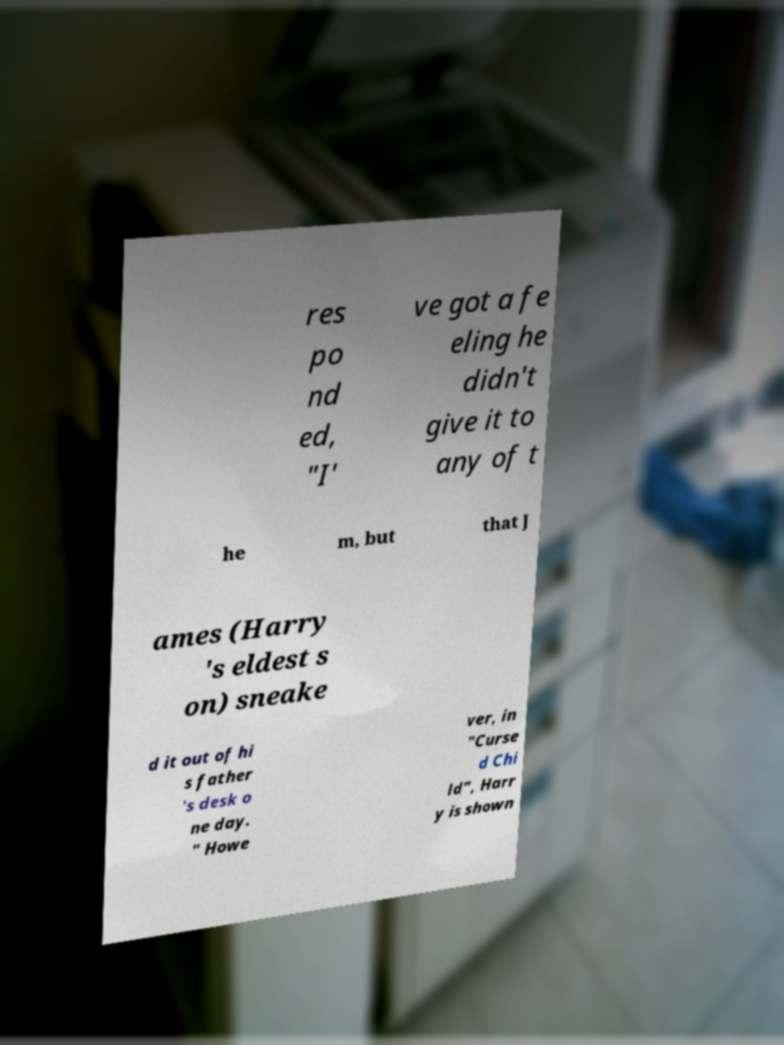Please read and relay the text visible in this image. What does it say? res po nd ed, "I' ve got a fe eling he didn't give it to any of t he m, but that J ames (Harry 's eldest s on) sneake d it out of hi s father 's desk o ne day. " Howe ver, in "Curse d Chi ld", Harr y is shown 